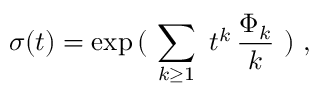<formula> <loc_0><loc_0><loc_500><loc_500>\sigma ( t ) = \exp \, ( \ \sum _ { k \geq 1 } \ t ^ { k } \, { \frac { \Phi _ { k } } { k } } \ ) \ ,</formula> 